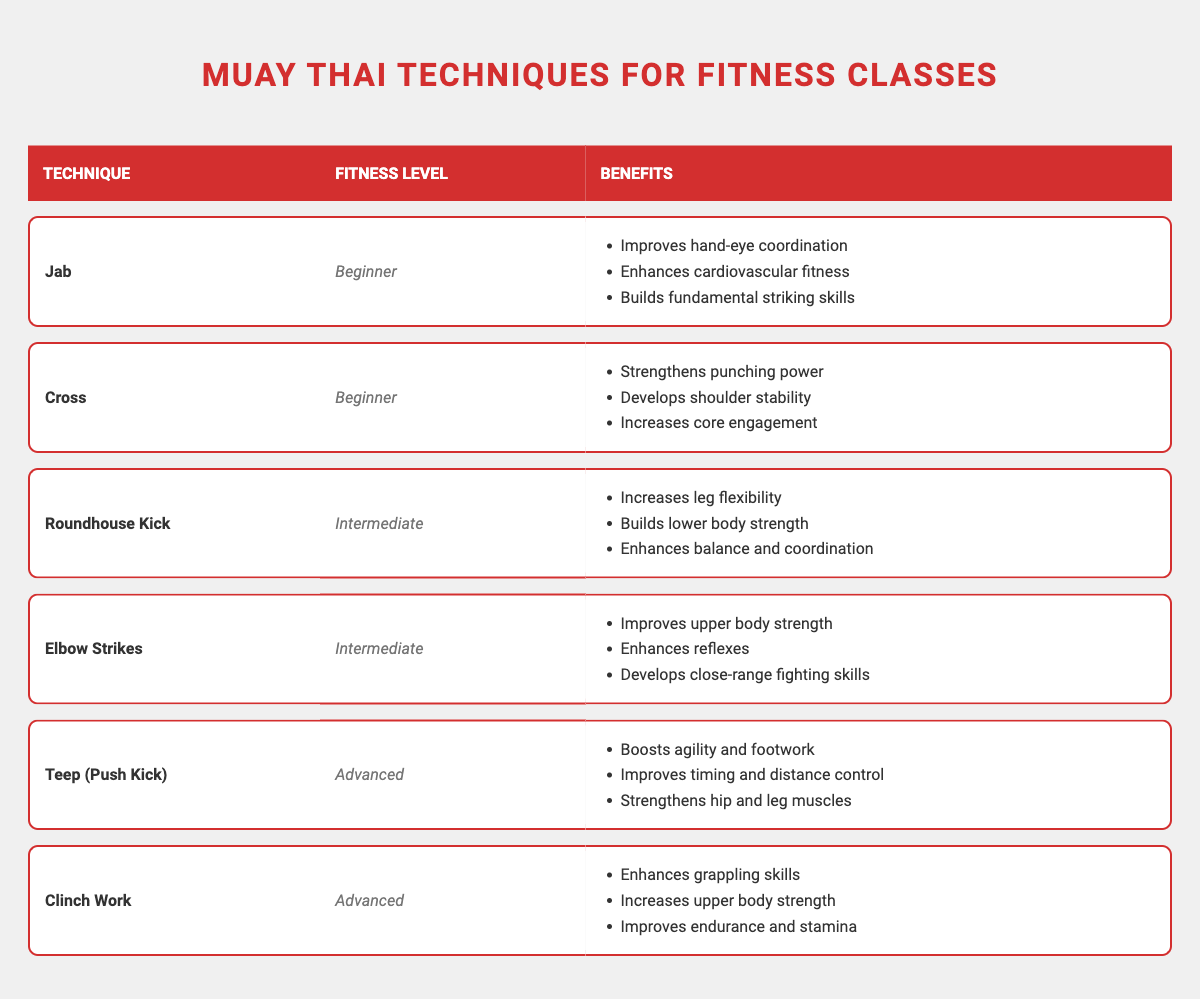What benefits does the Jab offer for beginners? The Jab offers three specific benefits for beginners: it improves hand-eye coordination, enhances cardiovascular fitness, and builds fundamental striking skills.
Answer: Improves hand-eye coordination, enhances cardiovascular fitness, builds fundamental striking skills What is the fitness level associated with Roundhouse Kick? The Roundhouse Kick is categorized under the Intermediate fitness level in the table.
Answer: Intermediate Is it true that Teep (Push Kick) improves core engagement? The table does not list core engagement as a benefit of Teep (Push Kick); rather, it focuses on agility, timing, and strength in the hips and legs. Therefore, the statement is false.
Answer: No How many techniques are listed for beginners? The table lists two techniques for beginners: Jab and Cross.
Answer: 2 Which technique has the most benefits listed? The table specifies that both the Teep (Push Kick) and Clinch Work techniques have three benefits each, while all other techniques have three as well. Therefore, they all have the same number of benefits listed.
Answer: All techniques have three benefits 